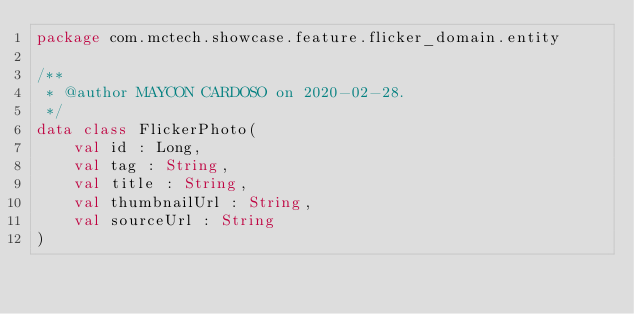<code> <loc_0><loc_0><loc_500><loc_500><_Kotlin_>package com.mctech.showcase.feature.flicker_domain.entity

/**
 * @author MAYCON CARDOSO on 2020-02-28.
 */
data class FlickerPhoto(
    val id : Long,
    val tag : String,
    val title : String,
    val thumbnailUrl : String,
    val sourceUrl : String
)</code> 